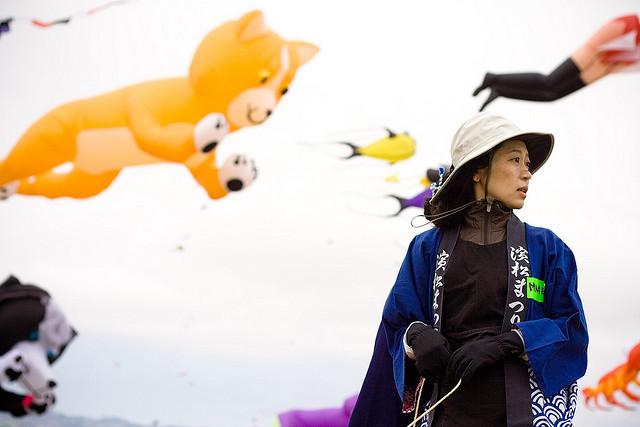Does the woman have on gloves?
Write a very short answer. Yes. Does the woman smile at the balloons?
Give a very brief answer. No. Is that a real bear?
Short answer required. No. 